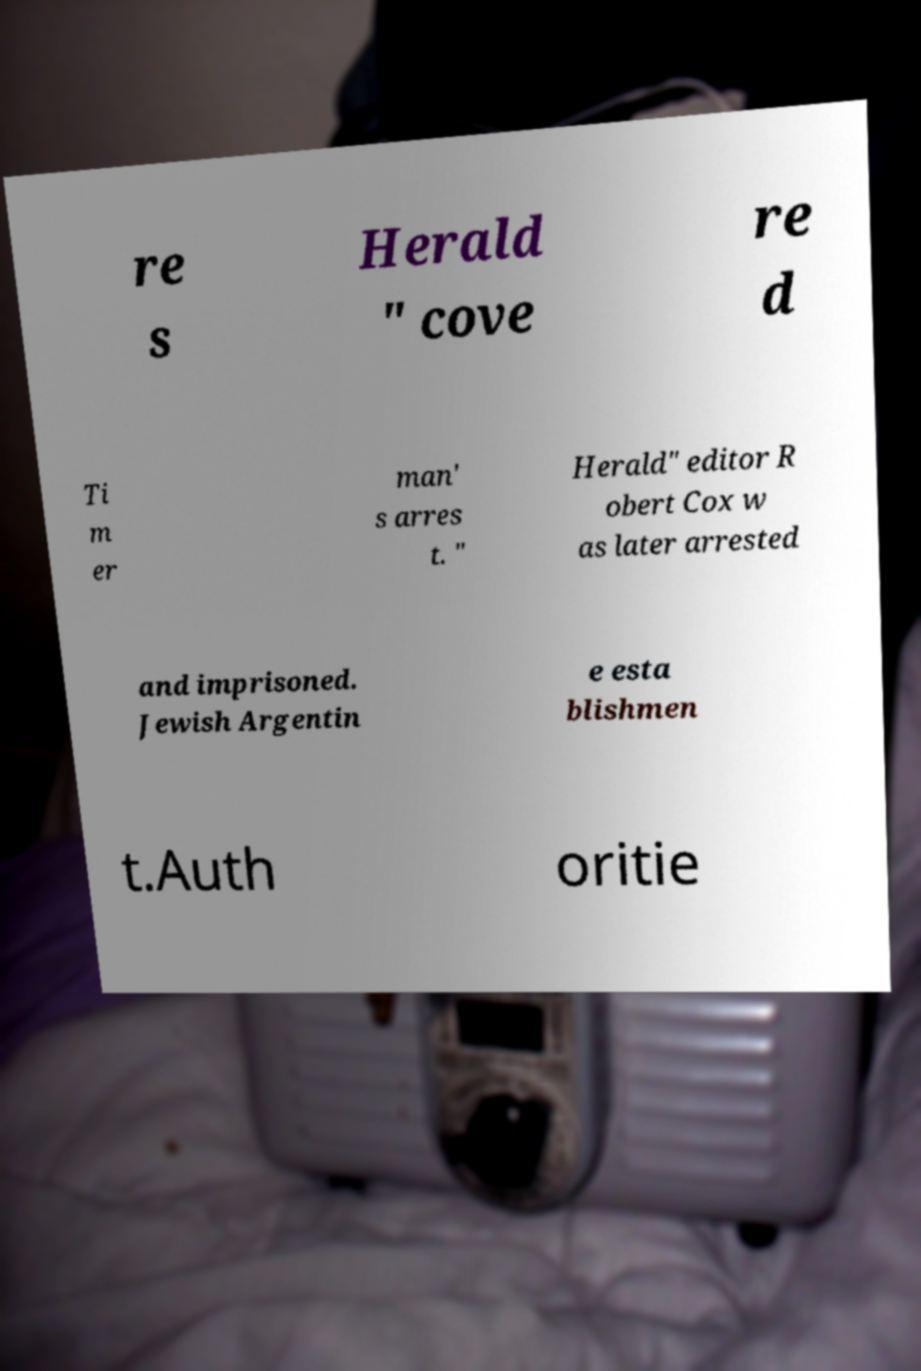Can you read and provide the text displayed in the image?This photo seems to have some interesting text. Can you extract and type it out for me? re s Herald " cove re d Ti m er man' s arres t. " Herald" editor R obert Cox w as later arrested and imprisoned. Jewish Argentin e esta blishmen t.Auth oritie 